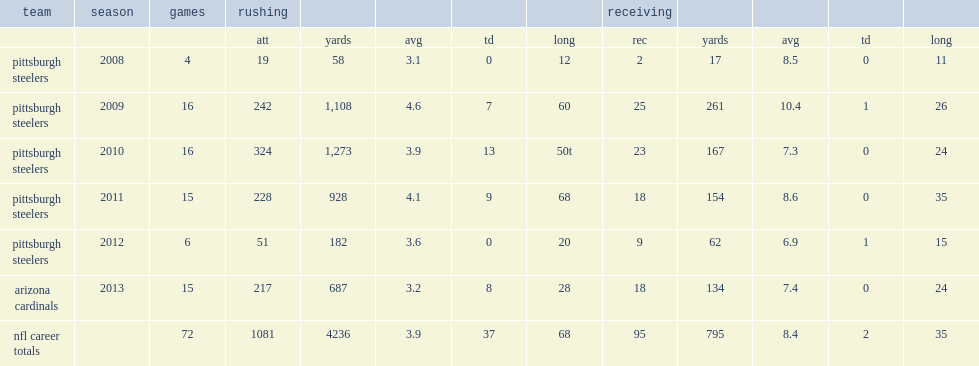How many rushing yards did mendenhall get in 2009? 1108.0. 